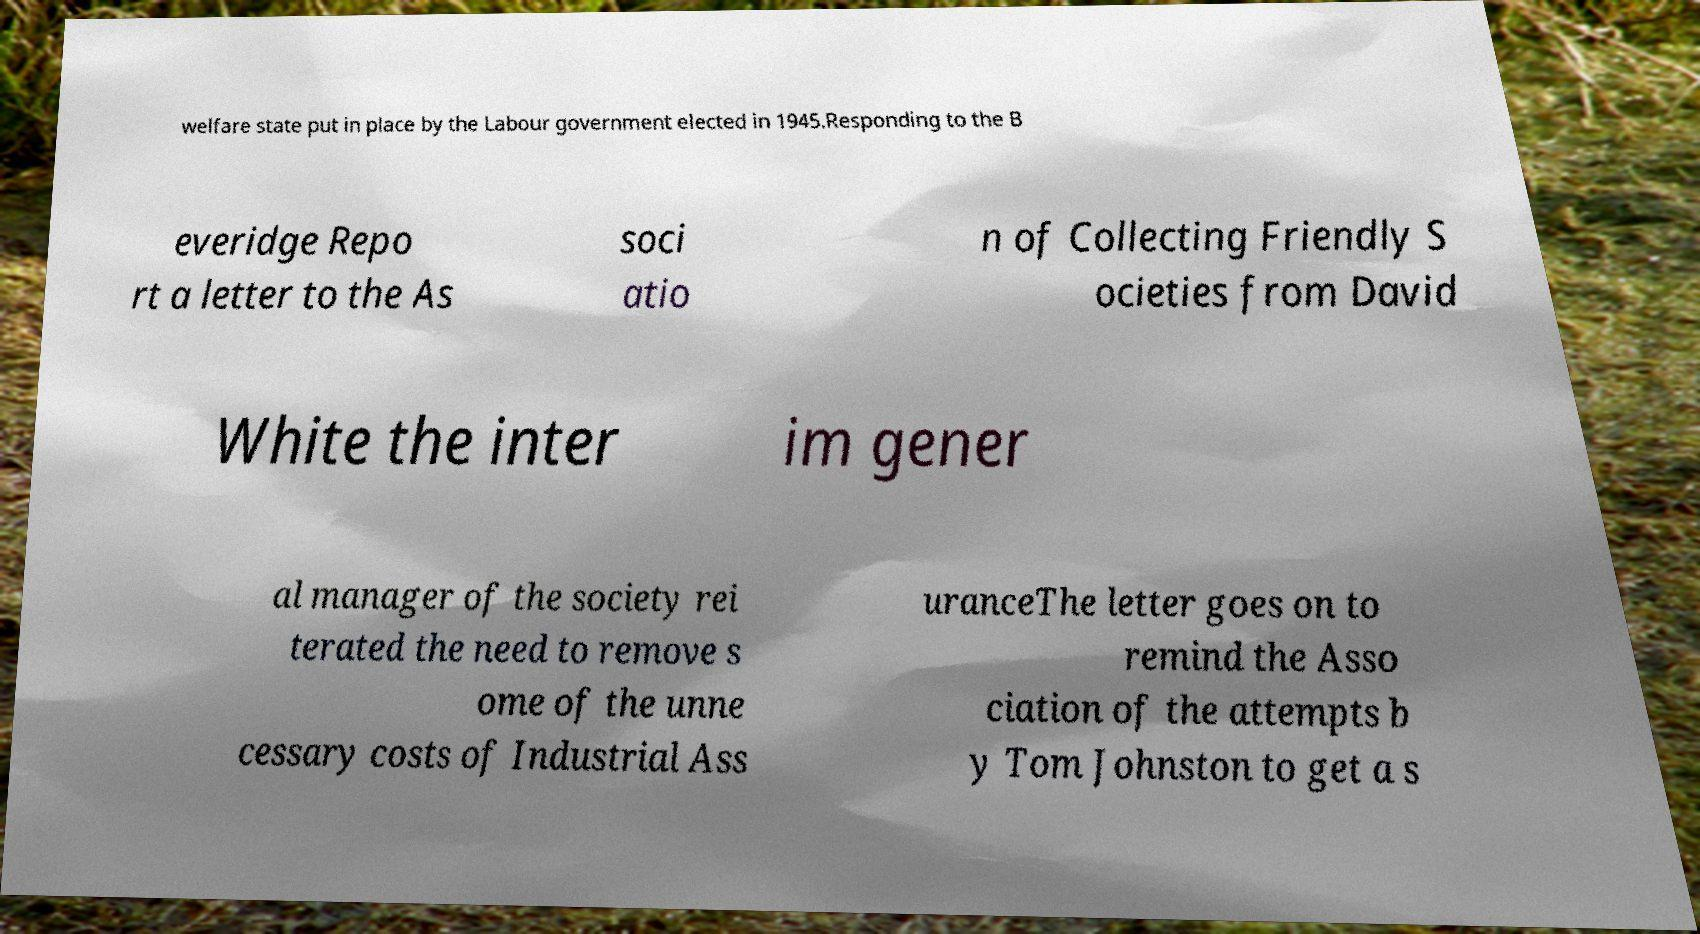Could you extract and type out the text from this image? welfare state put in place by the Labour government elected in 1945.Responding to the B everidge Repo rt a letter to the As soci atio n of Collecting Friendly S ocieties from David White the inter im gener al manager of the society rei terated the need to remove s ome of the unne cessary costs of Industrial Ass uranceThe letter goes on to remind the Asso ciation of the attempts b y Tom Johnston to get a s 